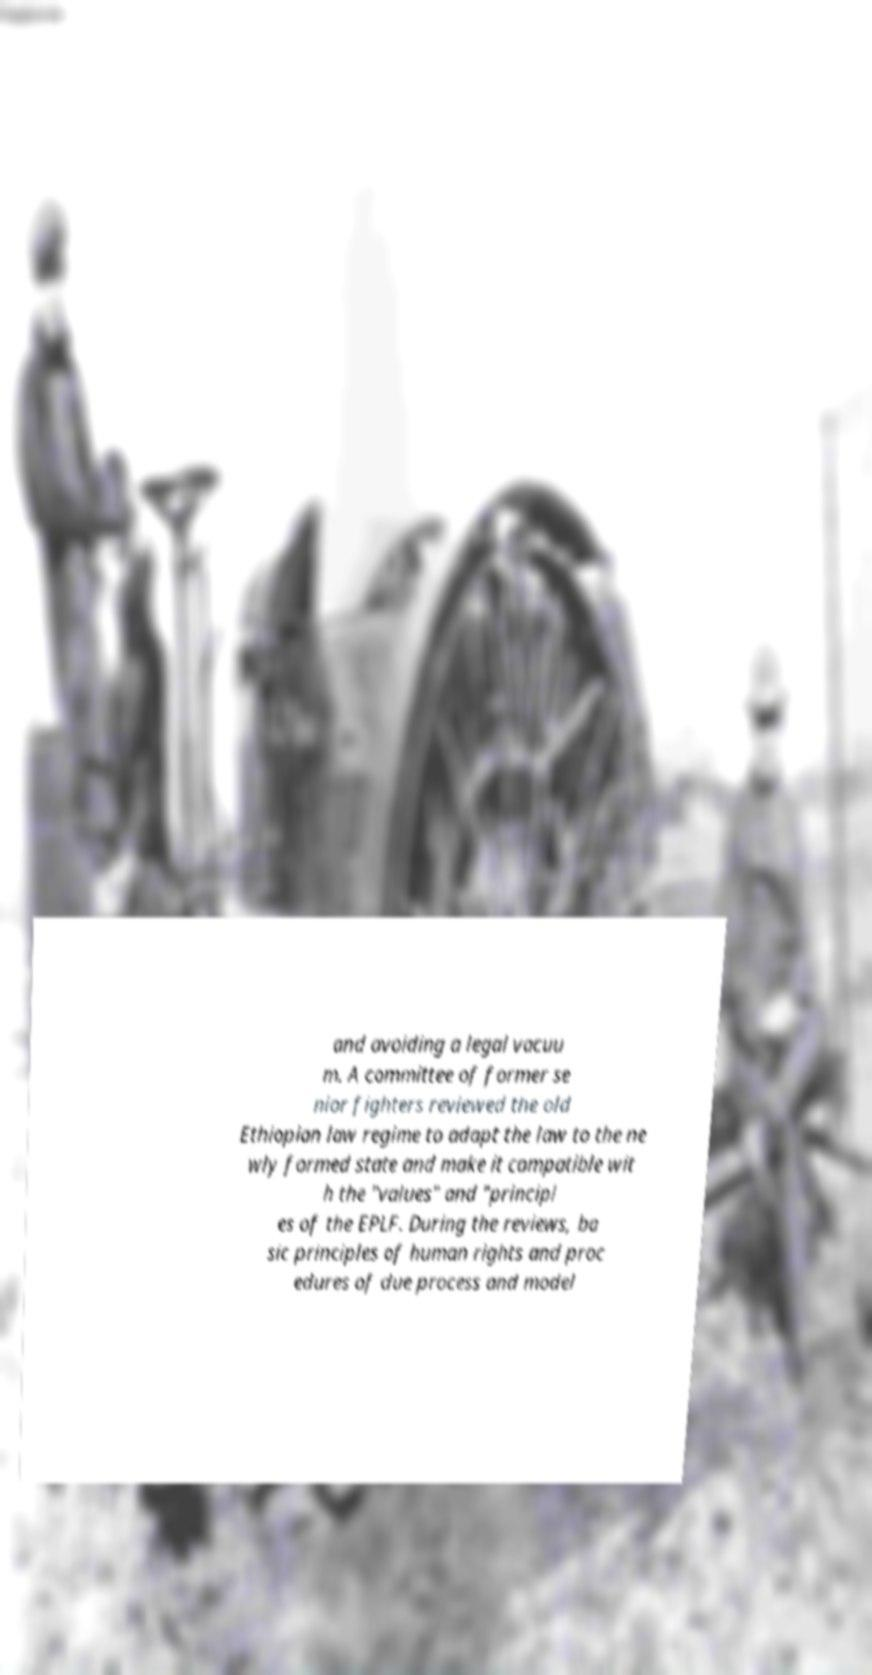I need the written content from this picture converted into text. Can you do that? and avoiding a legal vacuu m. A committee of former se nior fighters reviewed the old Ethiopian law regime to adapt the law to the ne wly formed state and make it compatible wit h the "values" and "principl es of the EPLF. During the reviews, ba sic principles of human rights and proc edures of due process and model 